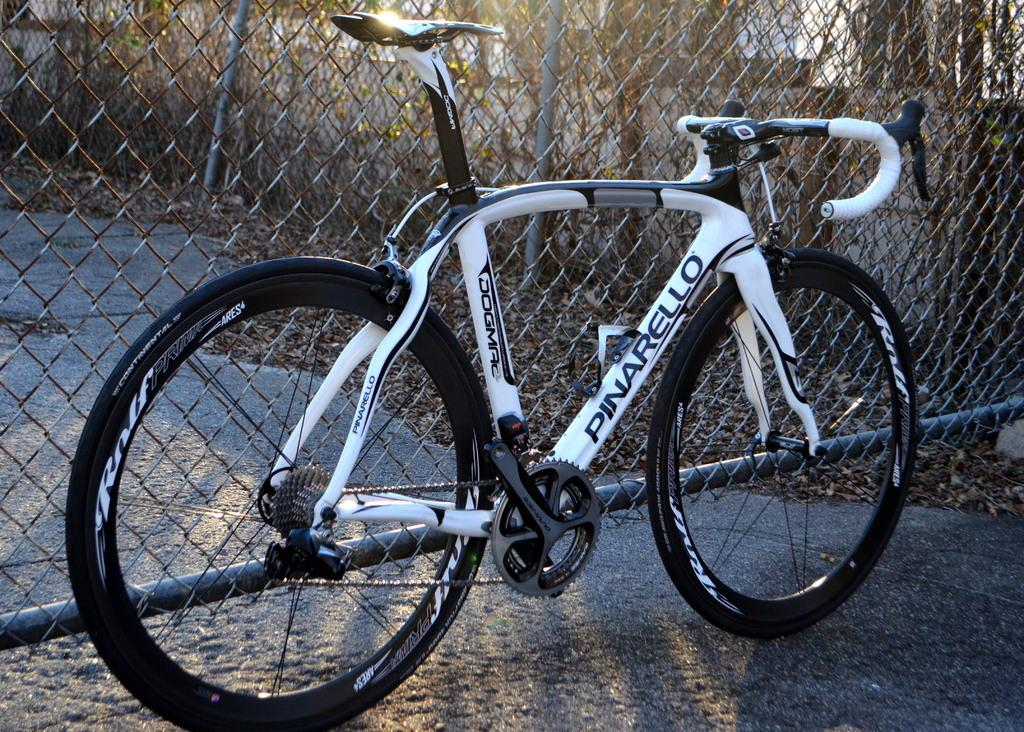What is the main object in the image? There is a cycle in the image. What is the color of the cycle? The cycle is white in color. What is present at the back side of the cycle? There is an iron net at the back side of the cycle. Can you see any curtains hanging from the cycle in the image? There are no curtains present in the image; it features a white cycle with an iron net at the back side. What type of vegetable is growing on the cycle in the image? There are no vegetables, such as cabbage, present in the image; it only features a white cycle with an iron net at the back side. 